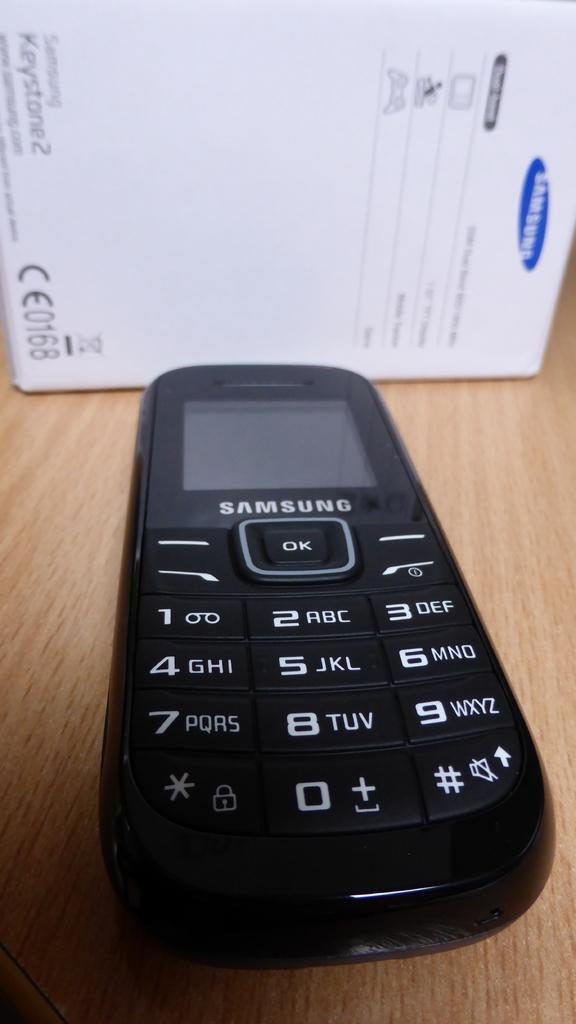What electronic device is visible in the image? There is a mobile phone in the image. What can be seen in the background of the image? There is a white color box in the background of the image. What type of surface is at the bottom of the image? There is a wooden surface at the bottom of the image. Which direction is the mobile phone facing in the image? The direction the mobile phone is facing cannot be determined from the image. What type of chain is present in the image? There is no chain present in the image. 